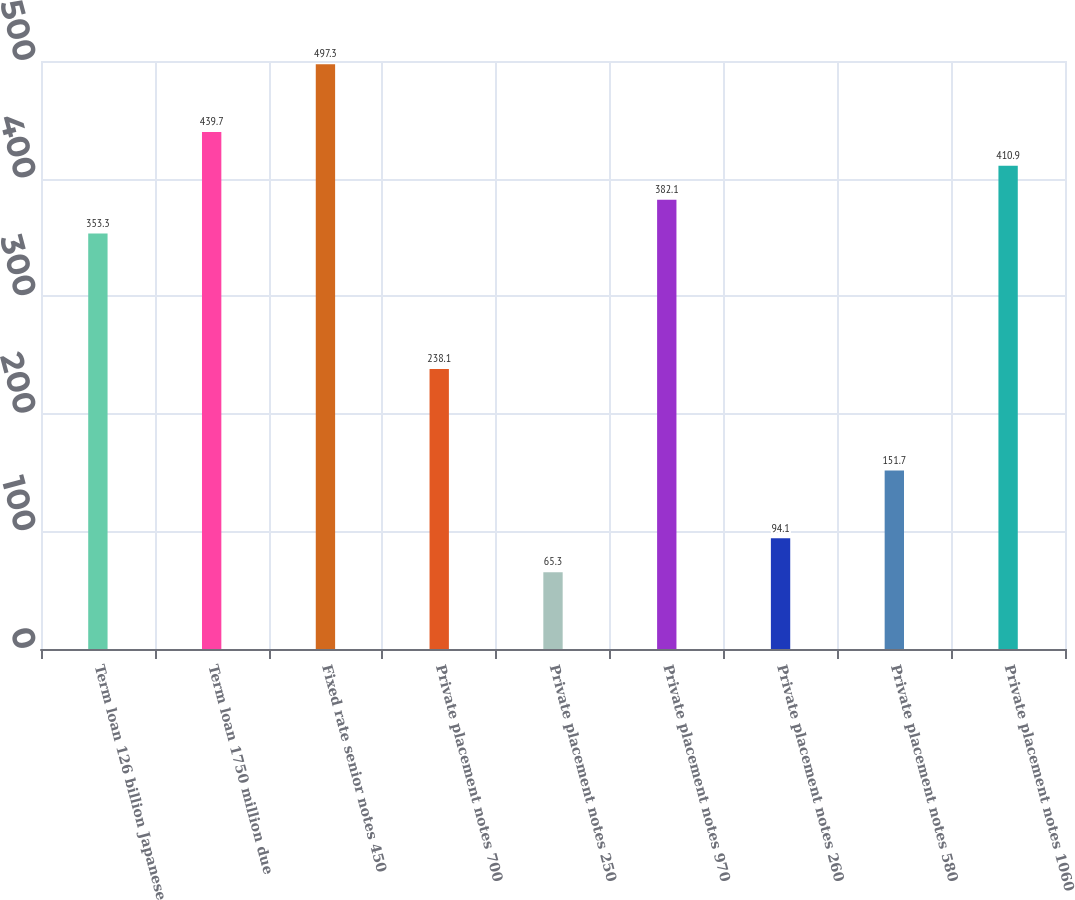Convert chart to OTSL. <chart><loc_0><loc_0><loc_500><loc_500><bar_chart><fcel>Term loan 126 billion Japanese<fcel>Term loan 1750 million due<fcel>Fixed rate senior notes 450<fcel>Private placement notes 700<fcel>Private placement notes 250<fcel>Private placement notes 970<fcel>Private placement notes 260<fcel>Private placement notes 580<fcel>Private placement notes 1060<nl><fcel>353.3<fcel>439.7<fcel>497.3<fcel>238.1<fcel>65.3<fcel>382.1<fcel>94.1<fcel>151.7<fcel>410.9<nl></chart> 